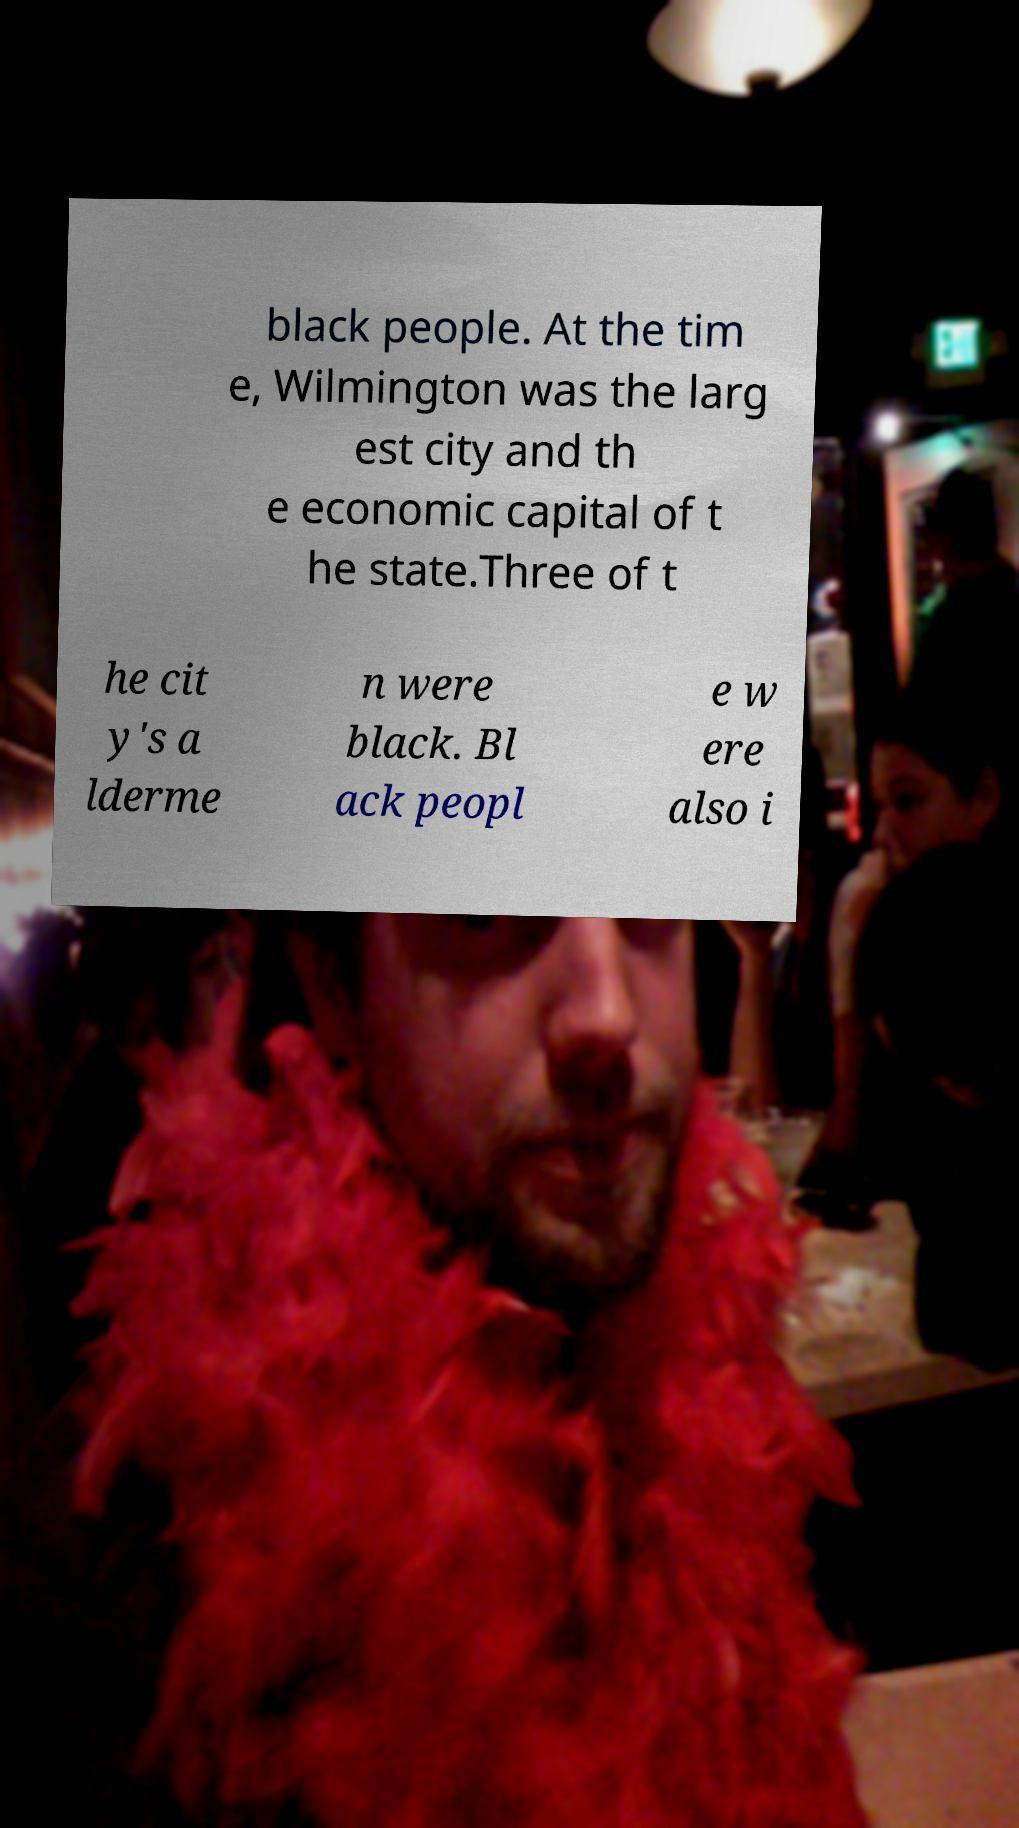I need the written content from this picture converted into text. Can you do that? black people. At the tim e, Wilmington was the larg est city and th e economic capital of t he state.Three of t he cit y's a lderme n were black. Bl ack peopl e w ere also i 